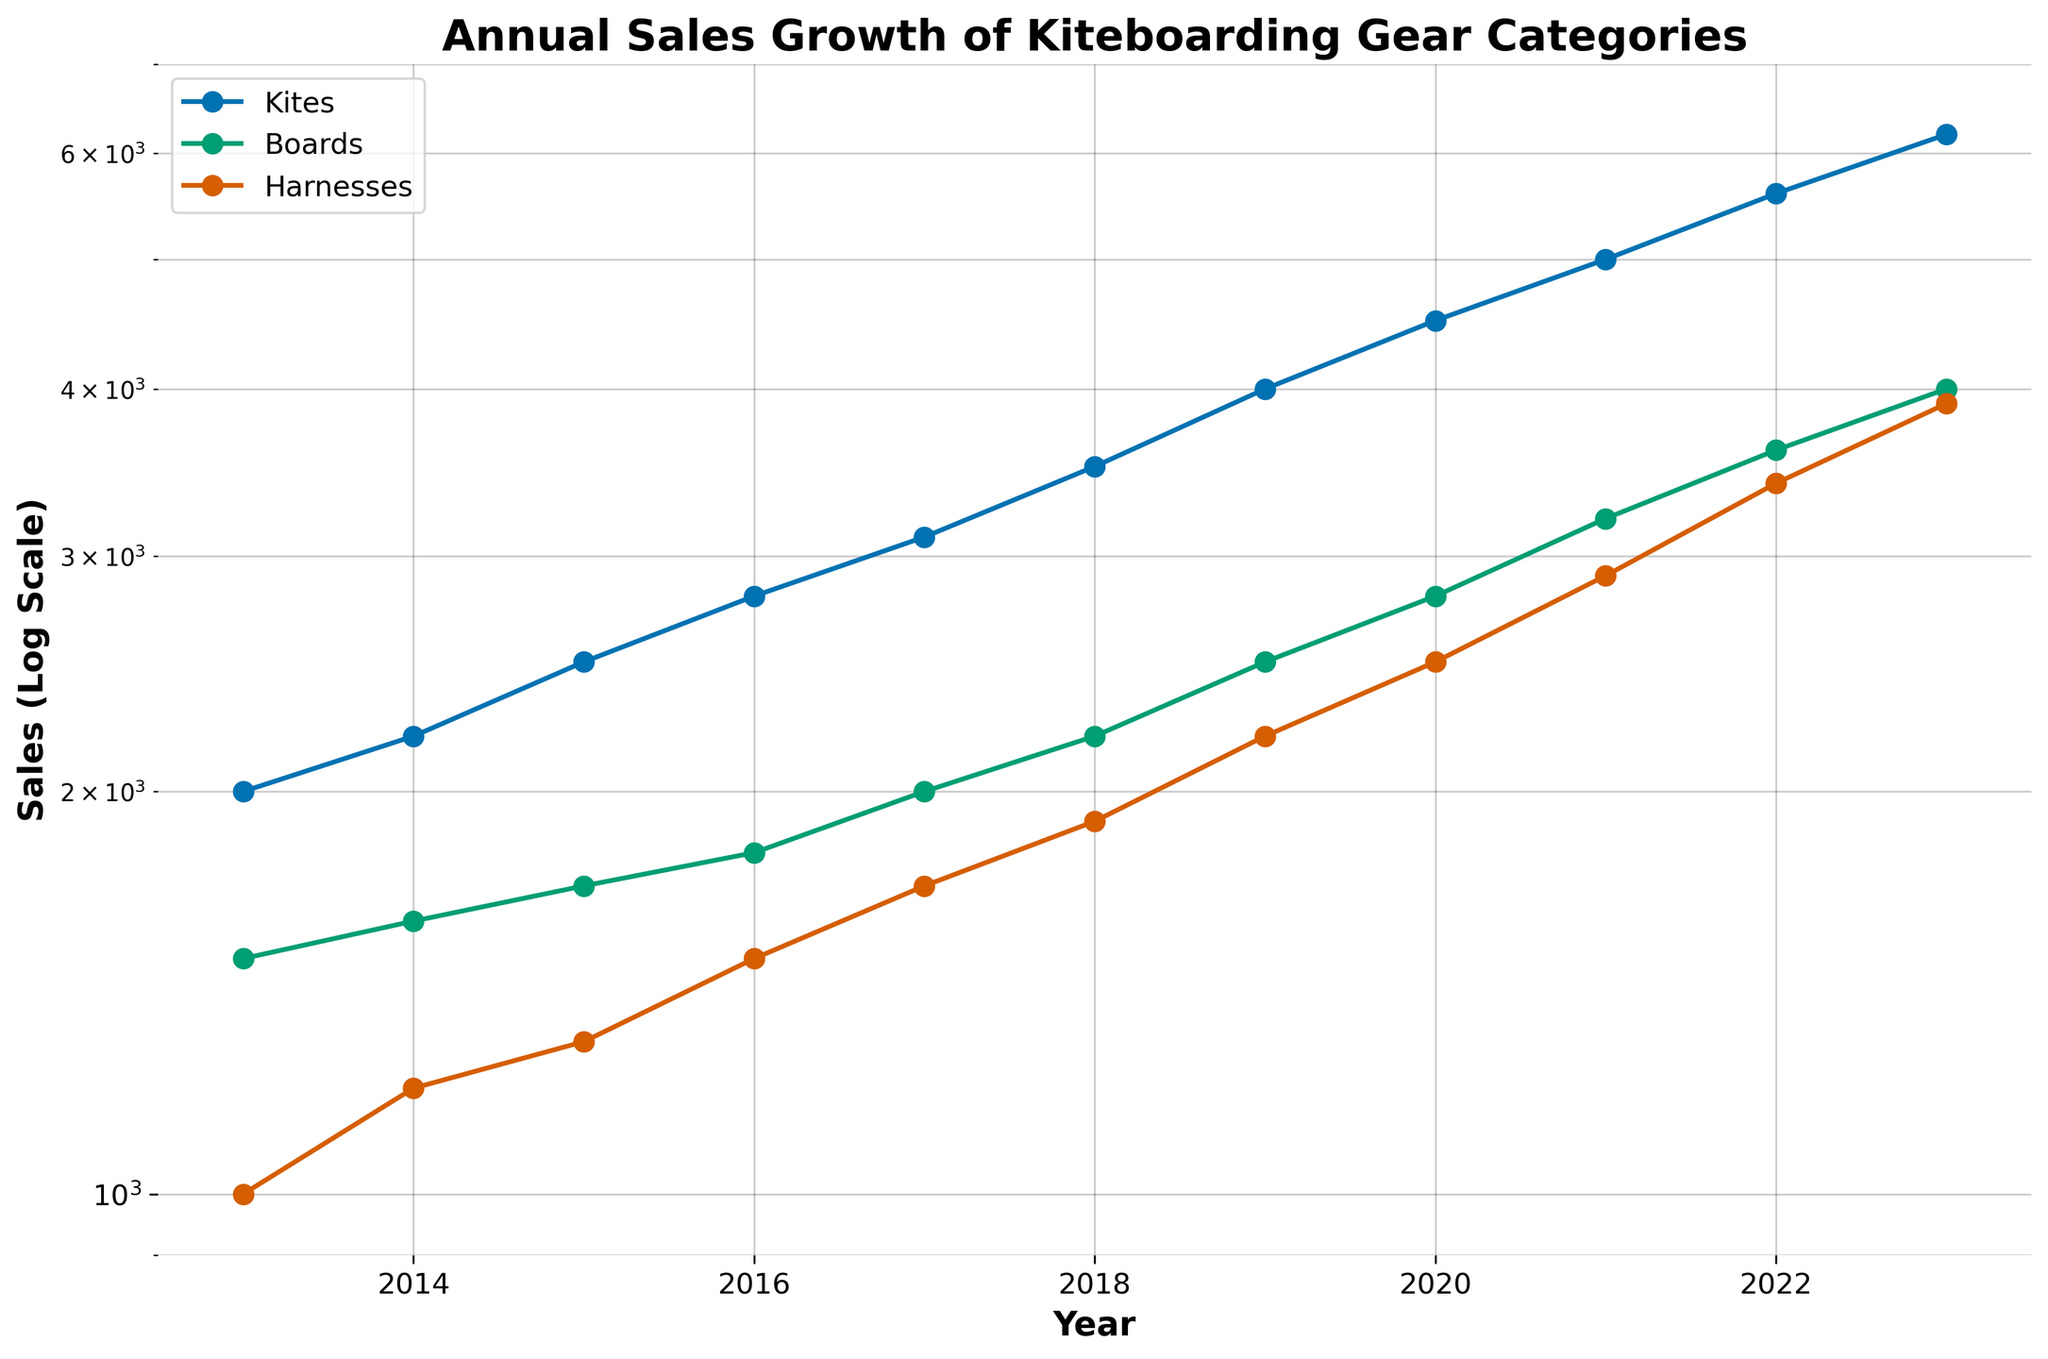What's the title of the plot? The title of the plot is displayed at the top of the figure.
Answer: Annual Sales Growth of Kiteboarding Gear Categories What are the three gear categories shown in the plot? The gear categories are listed in the legend or can be inferred from the different lines in the plot.
Answer: Kites, Boards, Harnesses What type of scale is used for the y-axis? The y-axis label indicates that a log scale is used.
Answer: Log scale How many years of data are displayed? Counting the number of x-axis ticks or data points on each line shows the number of years.
Answer: 11 years Which gear category had the highest sales in 2023? By looking at the endpoint of each line in 2023 and comparing their values, the highest point corresponds to the highest sales.
Answer: Kites What is the approximate sales value of Boards in 2018? Locate the point on the Boards line for the year 2018 and check its corresponding y-value on the log scale.
Answer: Approximately 2200 How did the sales of Harnesses change from 2014 to 2015? Compare the y-values of Harnesses between 2014 and 2015.
Answer: Increased by approximately 100 units Which gear category shows the most consistent growth over the decade? Analyze the slopes of the lines; the most consistent growth would exhibit the least fluctuations in slope.
Answer: Kites In which year did Boards exceed 3000 sales units for the first time? Trace the Boards line and look for the year when it first crosses the 3000 sales unit mark.
Answer: 2021 What is the difference in sales between Kites and Boards in 2020? Subtract the sales value of Boards from the sales value of Kites for the year 2020.
Answer: 1700 